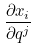Convert formula to latex. <formula><loc_0><loc_0><loc_500><loc_500>\frac { \partial x _ { i } } { \partial q ^ { j } }</formula> 